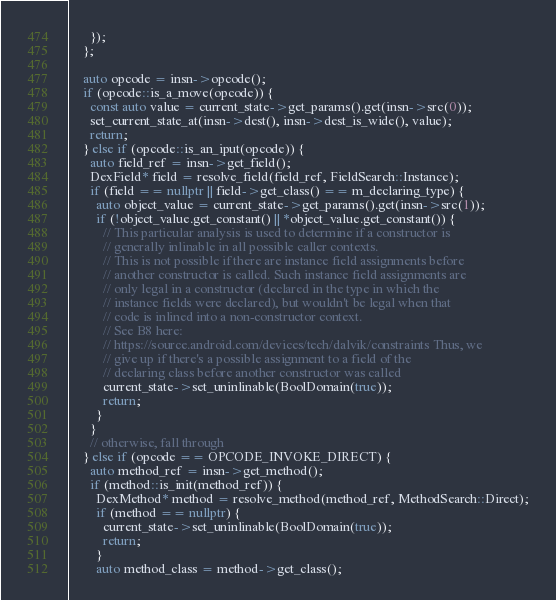Convert code to text. <code><loc_0><loc_0><loc_500><loc_500><_C++_>      });
    };

    auto opcode = insn->opcode();
    if (opcode::is_a_move(opcode)) {
      const auto value = current_state->get_params().get(insn->src(0));
      set_current_state_at(insn->dest(), insn->dest_is_wide(), value);
      return;
    } else if (opcode::is_an_iput(opcode)) {
      auto field_ref = insn->get_field();
      DexField* field = resolve_field(field_ref, FieldSearch::Instance);
      if (field == nullptr || field->get_class() == m_declaring_type) {
        auto object_value = current_state->get_params().get(insn->src(1));
        if (!object_value.get_constant() || *object_value.get_constant()) {
          // This particular analysis is used to determine if a constructor is
          // generally inlinable in all possible caller contexts.
          // This is not possible if there are instance field assignments before
          // another constructor is called. Such instance field assignments are
          // only legal in a constructor (declared in the type in which the
          // instance fields were declared), but wouldn't be legal when that
          // code is inlined into a non-constructor context.
          // See B8 here:
          // https://source.android.com/devices/tech/dalvik/constraints Thus, we
          // give up if there's a possible assignment to a field of the
          // declaring class before another constructor was called
          current_state->set_uninlinable(BoolDomain(true));
          return;
        }
      }
      // otherwise, fall through
    } else if (opcode == OPCODE_INVOKE_DIRECT) {
      auto method_ref = insn->get_method();
      if (method::is_init(method_ref)) {
        DexMethod* method = resolve_method(method_ref, MethodSearch::Direct);
        if (method == nullptr) {
          current_state->set_uninlinable(BoolDomain(true));
          return;
        }
        auto method_class = method->get_class();</code> 